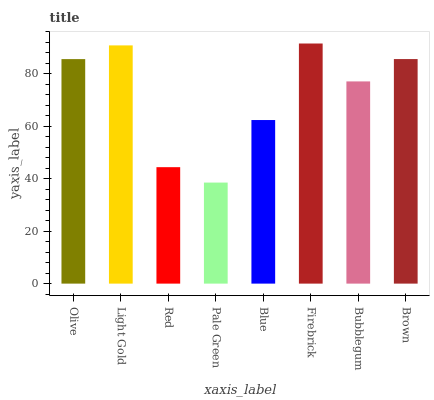Is Pale Green the minimum?
Answer yes or no. Yes. Is Firebrick the maximum?
Answer yes or no. Yes. Is Light Gold the minimum?
Answer yes or no. No. Is Light Gold the maximum?
Answer yes or no. No. Is Light Gold greater than Olive?
Answer yes or no. Yes. Is Olive less than Light Gold?
Answer yes or no. Yes. Is Olive greater than Light Gold?
Answer yes or no. No. Is Light Gold less than Olive?
Answer yes or no. No. Is Olive the high median?
Answer yes or no. Yes. Is Bubblegum the low median?
Answer yes or no. Yes. Is Red the high median?
Answer yes or no. No. Is Red the low median?
Answer yes or no. No. 